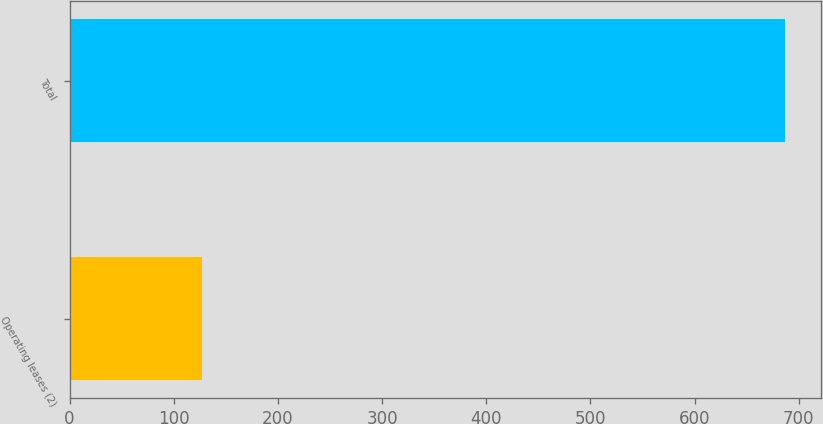Convert chart to OTSL. <chart><loc_0><loc_0><loc_500><loc_500><bar_chart><fcel>Operating leases (2)<fcel>Total<nl><fcel>127<fcel>686.5<nl></chart> 